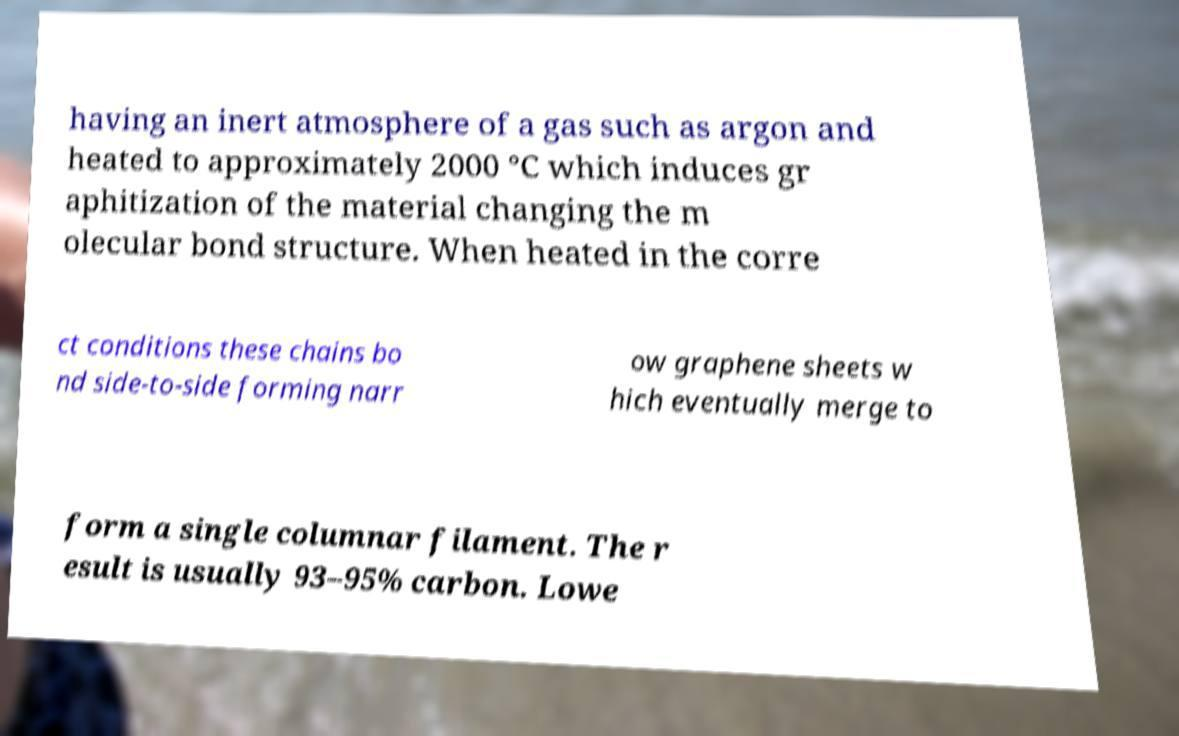For documentation purposes, I need the text within this image transcribed. Could you provide that? having an inert atmosphere of a gas such as argon and heated to approximately 2000 °C which induces gr aphitization of the material changing the m olecular bond structure. When heated in the corre ct conditions these chains bo nd side-to-side forming narr ow graphene sheets w hich eventually merge to form a single columnar filament. The r esult is usually 93–95% carbon. Lowe 